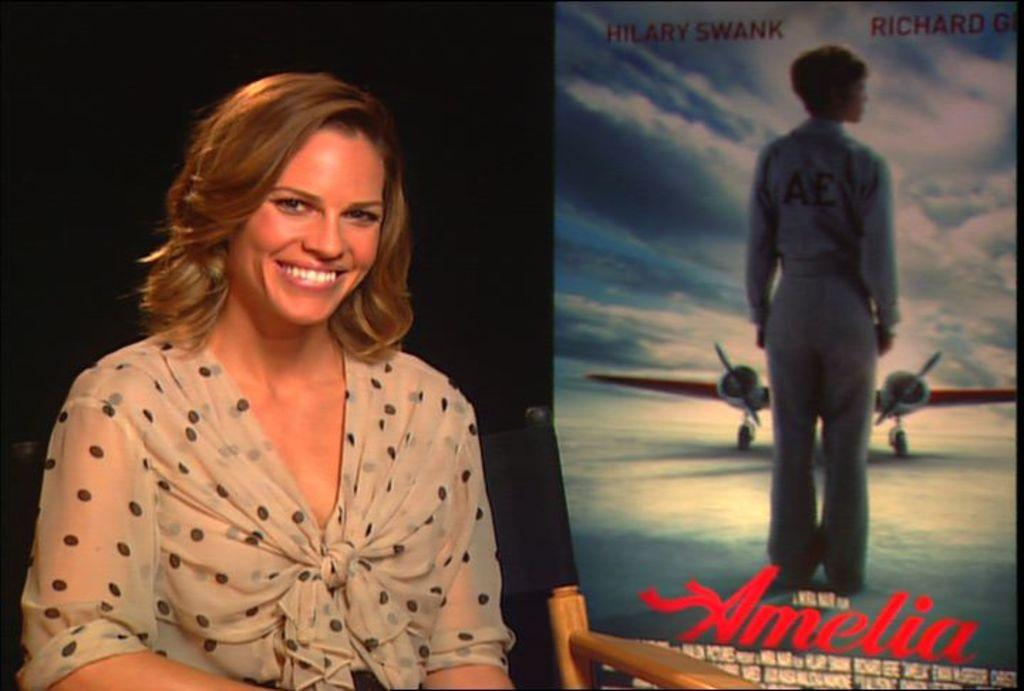What is the person in the image doing? The person is sitting on a chair in the image. What can be seen on the right side of the image? There is a poster on the right side of the image. What is depicted on the poster? The poster contains an airplane, a person, and some text. What type of stitch is being used to sew the drain on the top of the poster? There is no stitch, drain, or top present on the poster or in the image. 